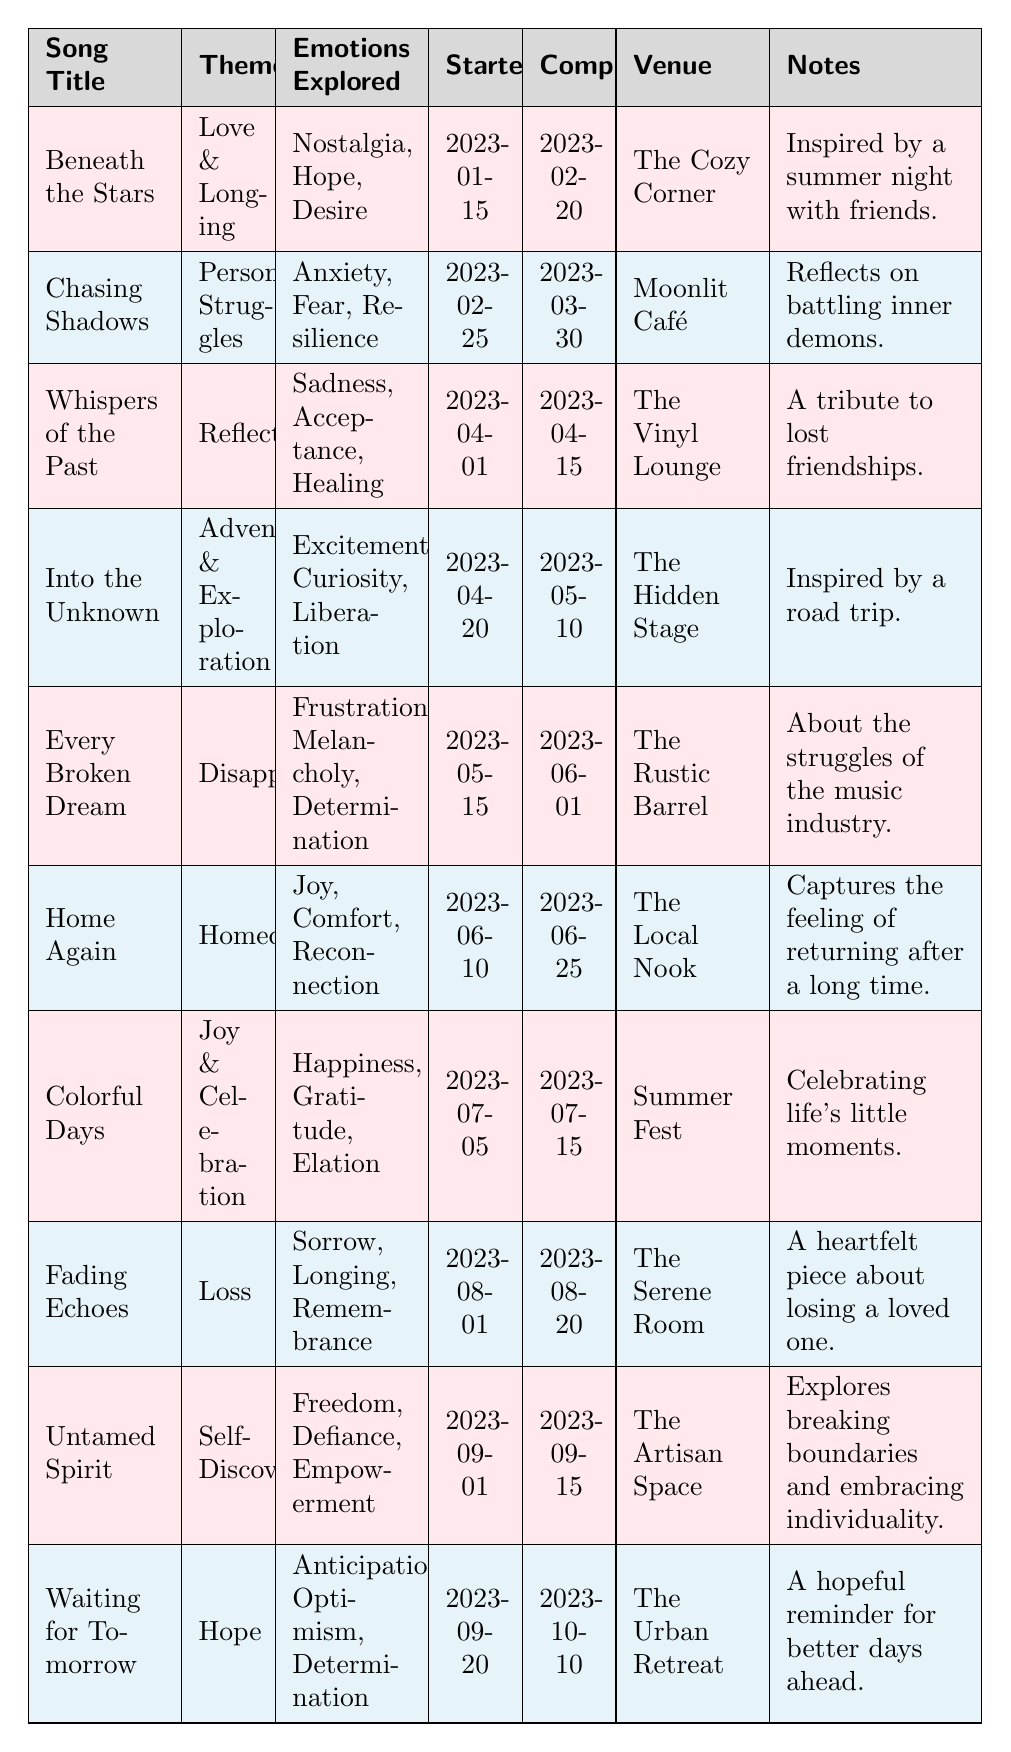What is the theme of the song "Every Broken Dream"? The table lists the theme of "Every Broken Dream" as "Disappointment."
Answer: Disappointment How many songs explore the emotion of "Hope"? The songs "Beneath the Stars," "Waiting for Tomorrow," and "Home Again" explore the emotion of "Hope," totaling three songs.
Answer: 3 Which venue hosted the performance of "Colorful Days"? According to the table, "Colorful Days" was performed at "Summer Fest."
Answer: Summer Fest What emotion is explored in the song "Fading Echoes"? The song "Fading Echoes" explores the emotions of "Sorrow," "Longing," and "Remembrance."
Answer: Sorrow, Longing, Remembrance Which song was completed first, "Into the Unknown" or "Waiting for Tomorrow"? "Into the Unknown" was completed on 2023-05-10, while "Waiting for Tomorrow" was completed on 2023-10-10, making "Into the Unknown" the first completed song.
Answer: Into the Unknown How many songs have the theme "Reflection"? The table shows that there is only one song with the theme "Reflection," which is "Whispers of the Past."
Answer: 1 Which song has the most positive emotions explored, and what are they? The song "Colorful Days" explores the positive emotions of "Happiness," "Gratitude," and "Elation," making it the one with the most positive emotions.
Answer: Colorful Days; Happiness, Gratitude, Elation Is there a song that explores both "Resilience" and "Hope"? The table indicates that "Chasing Shadows" explores "Resilience," but no song is listed as exploring "Hope" along with it, so the answer is no.
Answer: No Which two songs have emotions related to nostalgia and sadness? "Beneath the Stars" has the emotion of "Nostalgia," and "Whispers of the Past" explores "Sadness." Thus, they are the two songs related to those emotions.
Answer: Beneath the Stars; Whispers of the Past What is the time span between starting and completing "Home Again"? "Home Again" started on 2023-06-10 and was completed on 2023-06-25, giving a time span of 15 days.
Answer: 15 days How many songs were performed at "The Urban Retreat"? The table shows only one song, "Waiting for Tomorrow," performed at "The Urban Retreat."
Answer: 1 